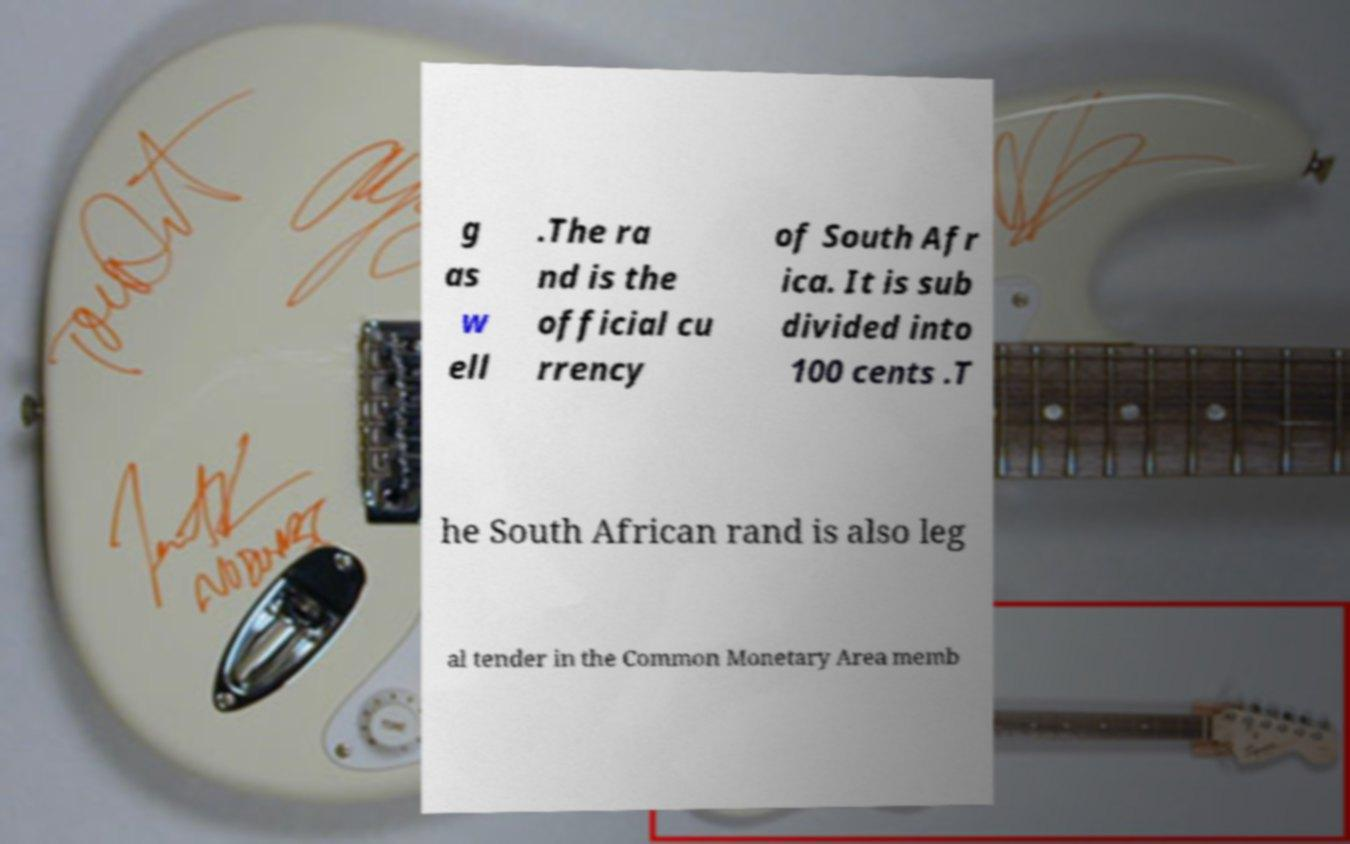What messages or text are displayed in this image? I need them in a readable, typed format. g as w ell .The ra nd is the official cu rrency of South Afr ica. It is sub divided into 100 cents .T he South African rand is also leg al tender in the Common Monetary Area memb 